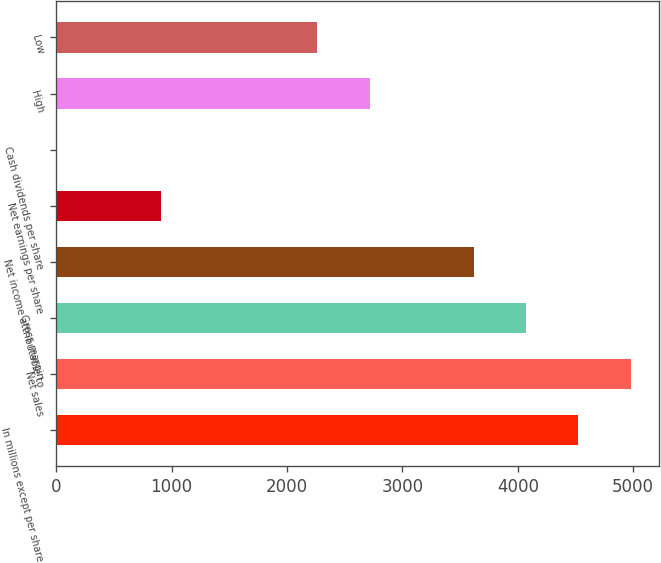Convert chart. <chart><loc_0><loc_0><loc_500><loc_500><bar_chart><fcel>In millions except per share<fcel>Net sales<fcel>Gross margin<fcel>Net income attributable to<fcel>Net earnings per share<fcel>Cash dividends per share<fcel>High<fcel>Low<nl><fcel>4525<fcel>4977.45<fcel>4072.55<fcel>3620.1<fcel>905.4<fcel>0.5<fcel>2715.2<fcel>2262.75<nl></chart> 